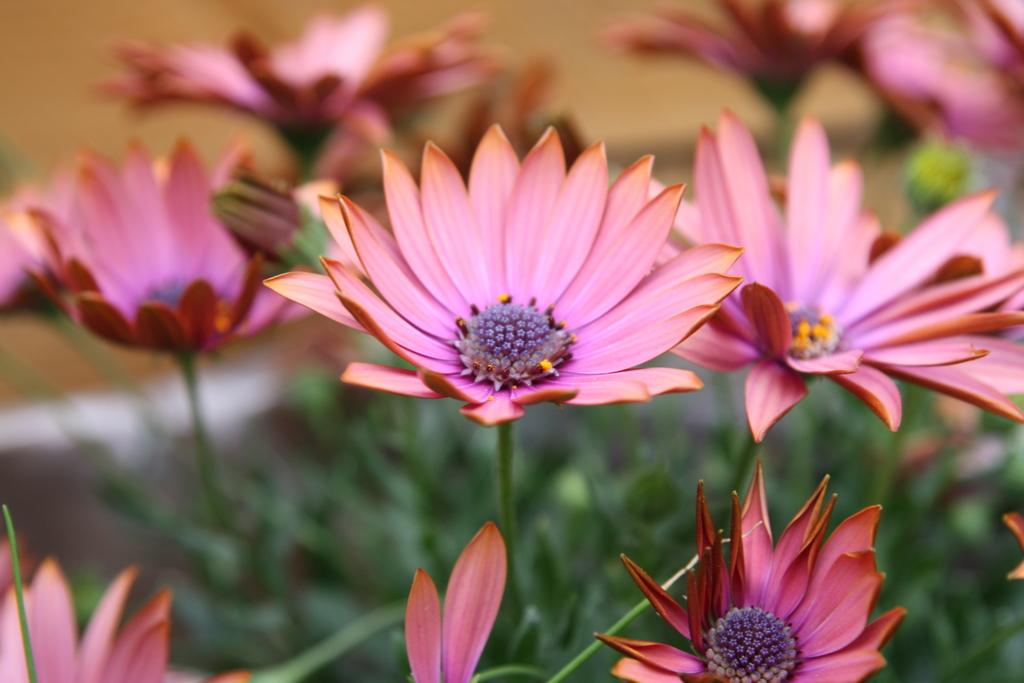What type of living organisms can be seen in the image? There are flowers and plants visible in the image. What is located behind the flowers in the image? There is a wall behind the flowers. Can you tell me how many ships are docked in the harbor in the image? There is no harbor or ships present in the image; it features flowers and plants with a wall in the background. What type of verse is recited by the soldiers during the battle in the image? There is no battle or soldiers present in the image; it features flowers and plants with a wall in the background. 